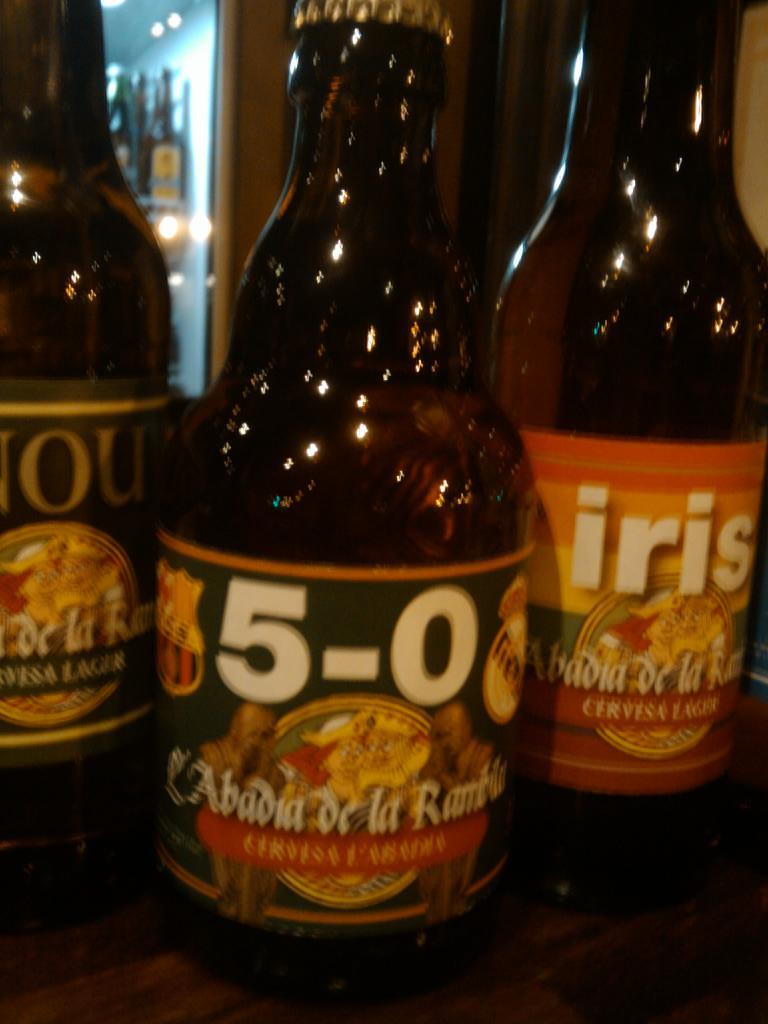What type of containers are visible in the image? There are beverage bottles in the image. Where are the beverage bottles located? The beverage bottles are placed on a surface. How many cows are visible in the image? There are no cows present in the image. 